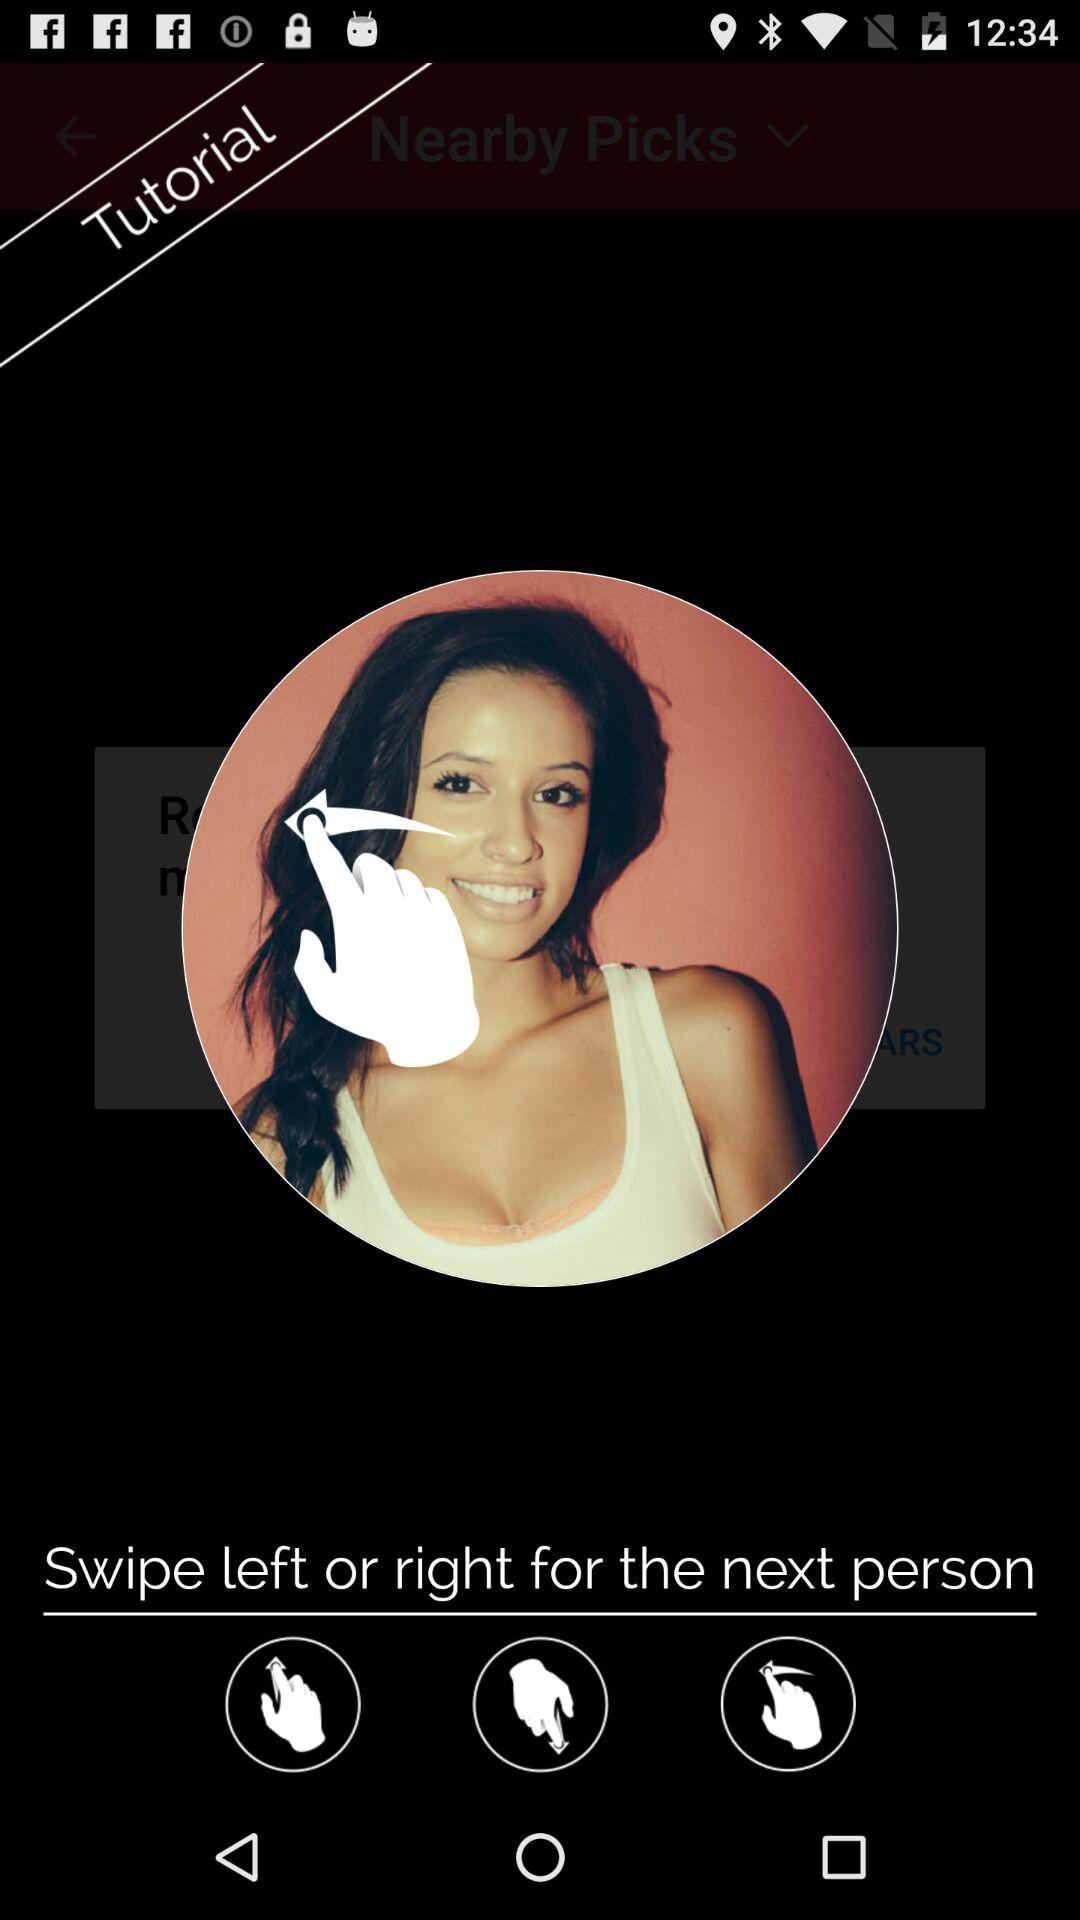What to do for the next person? For the next person, swipe left or right. 